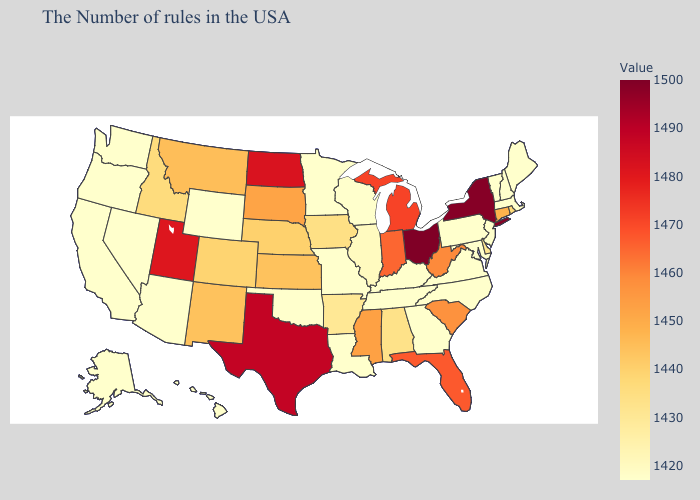Which states have the highest value in the USA?
Short answer required. Ohio. Does Idaho have the lowest value in the USA?
Write a very short answer. No. Among the states that border Indiana , which have the highest value?
Give a very brief answer. Ohio. Which states have the highest value in the USA?
Quick response, please. Ohio. 